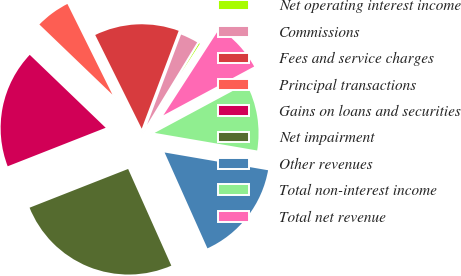Convert chart to OTSL. <chart><loc_0><loc_0><loc_500><loc_500><pie_chart><fcel>Net operating interest income<fcel>Commissions<fcel>Fees and service charges<fcel>Principal transactions<fcel>Gains on loans and securities<fcel>Net impairment<fcel>Other revenues<fcel>Total non-interest income<fcel>Total net revenue<nl><fcel>0.43%<fcel>2.96%<fcel>13.08%<fcel>5.49%<fcel>18.14%<fcel>25.73%<fcel>15.61%<fcel>10.55%<fcel>8.02%<nl></chart> 